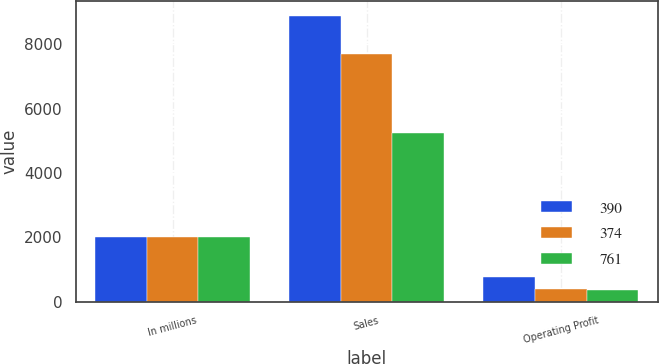Convert chart. <chart><loc_0><loc_0><loc_500><loc_500><stacked_bar_chart><ecel><fcel>In millions<fcel>Sales<fcel>Operating Profit<nl><fcel>390<fcel>2009<fcel>8890<fcel>761<nl><fcel>374<fcel>2008<fcel>7690<fcel>390<nl><fcel>761<fcel>2007<fcel>5245<fcel>374<nl></chart> 